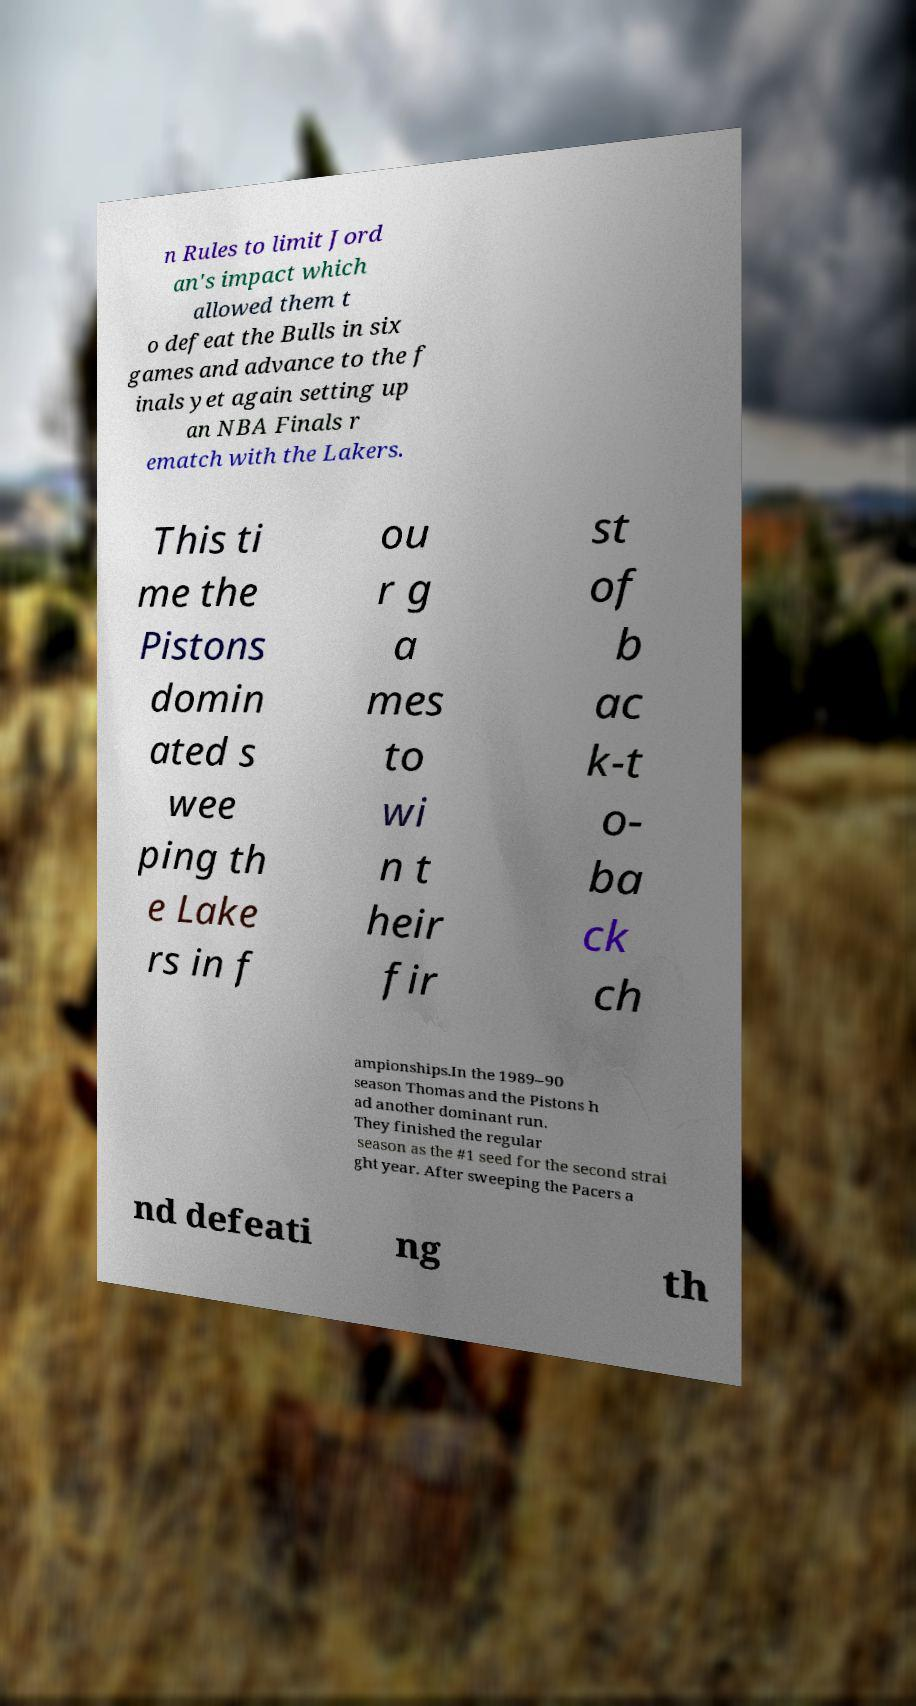Please identify and transcribe the text found in this image. n Rules to limit Jord an's impact which allowed them t o defeat the Bulls in six games and advance to the f inals yet again setting up an NBA Finals r ematch with the Lakers. This ti me the Pistons domin ated s wee ping th e Lake rs in f ou r g a mes to wi n t heir fir st of b ac k-t o- ba ck ch ampionships.In the 1989–90 season Thomas and the Pistons h ad another dominant run. They finished the regular season as the #1 seed for the second strai ght year. After sweeping the Pacers a nd defeati ng th 